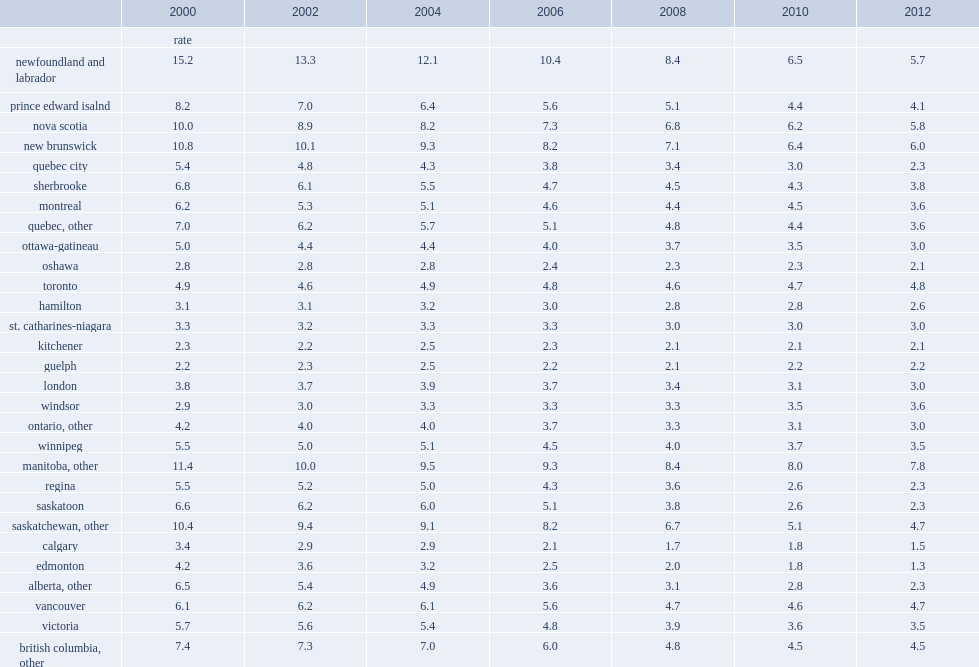What was the range of comparison group rates in 2012? 1.3 6.0. 